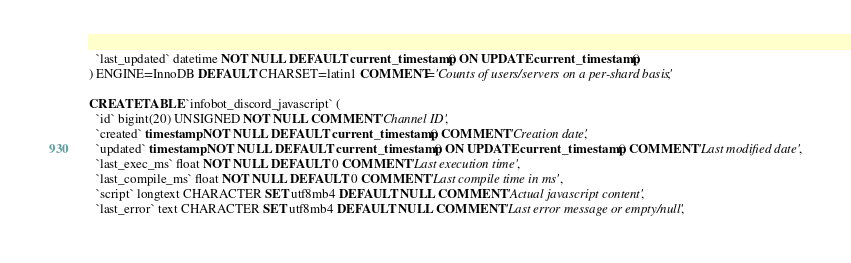<code> <loc_0><loc_0><loc_500><loc_500><_SQL_>  `last_updated` datetime NOT NULL DEFAULT current_timestamp() ON UPDATE current_timestamp()
) ENGINE=InnoDB DEFAULT CHARSET=latin1 COMMENT='Counts of users/servers on a per-shard basis';

CREATE TABLE `infobot_discord_javascript` (
  `id` bigint(20) UNSIGNED NOT NULL COMMENT 'Channel ID',
  `created` timestamp NOT NULL DEFAULT current_timestamp() COMMENT 'Creation date',
  `updated` timestamp NOT NULL DEFAULT current_timestamp() ON UPDATE current_timestamp() COMMENT 'Last modified date',
  `last_exec_ms` float NOT NULL DEFAULT 0 COMMENT 'Last execution time',
  `last_compile_ms` float NOT NULL DEFAULT 0 COMMENT 'Last compile time in ms',
  `script` longtext CHARACTER SET utf8mb4 DEFAULT NULL COMMENT 'Actual javascript content',
  `last_error` text CHARACTER SET utf8mb4 DEFAULT NULL COMMENT 'Last error message or empty/null',</code> 